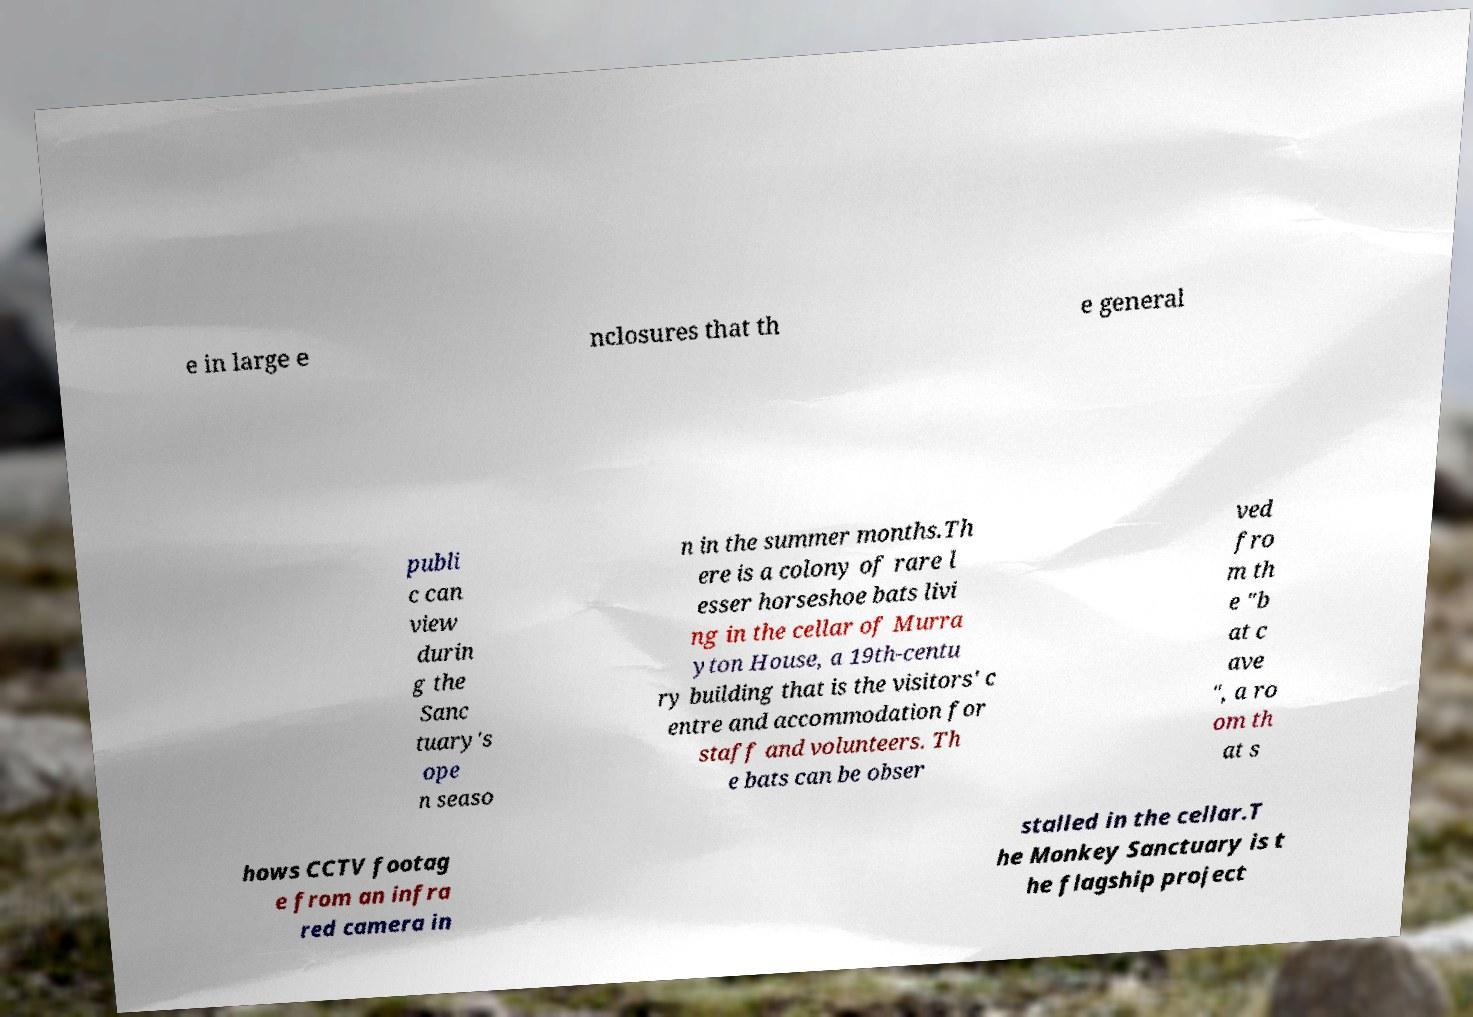What messages or text are displayed in this image? I need them in a readable, typed format. e in large e nclosures that th e general publi c can view durin g the Sanc tuary's ope n seaso n in the summer months.Th ere is a colony of rare l esser horseshoe bats livi ng in the cellar of Murra yton House, a 19th-centu ry building that is the visitors' c entre and accommodation for staff and volunteers. Th e bats can be obser ved fro m th e "b at c ave ", a ro om th at s hows CCTV footag e from an infra red camera in stalled in the cellar.T he Monkey Sanctuary is t he flagship project 